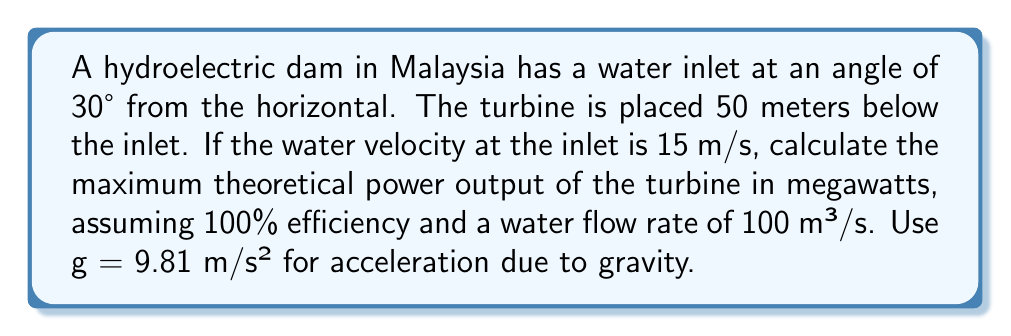Teach me how to tackle this problem. 1) First, we need to calculate the total head (H) of the dam. This includes both the height difference and the velocity head:

   Height difference: $h = 50 \text{ m}$
   Velocity head: $h_v = \frac{v^2}{2g} = \frac{15^2}{2(9.81)} = 11.47 \text{ m}$

   Total head: $H = h + h_v = 50 + 11.47 = 61.47 \text{ m}$

2) The theoretical power output is given by the equation:

   $$P = \rho g Q H$$

   Where:
   $\rho$ = density of water (1000 kg/m³)
   $g$ = acceleration due to gravity (9.81 m/s²)
   $Q$ = flow rate (100 m³/s)
   $H$ = total head (61.47 m)

3) Substituting these values:

   $$P = 1000 \cdot 9.81 \cdot 100 \cdot 61.47 = 60,301,470 \text{ W}$$

4) Converting to megawatts:

   $$P = 60,301,470 \text{ W} \cdot \frac{1 \text{ MW}}{1,000,000 \text{ W}} = 60.30 \text{ MW}$$

Therefore, the maximum theoretical power output of the turbine is 60.30 MW.
Answer: 60.30 MW 